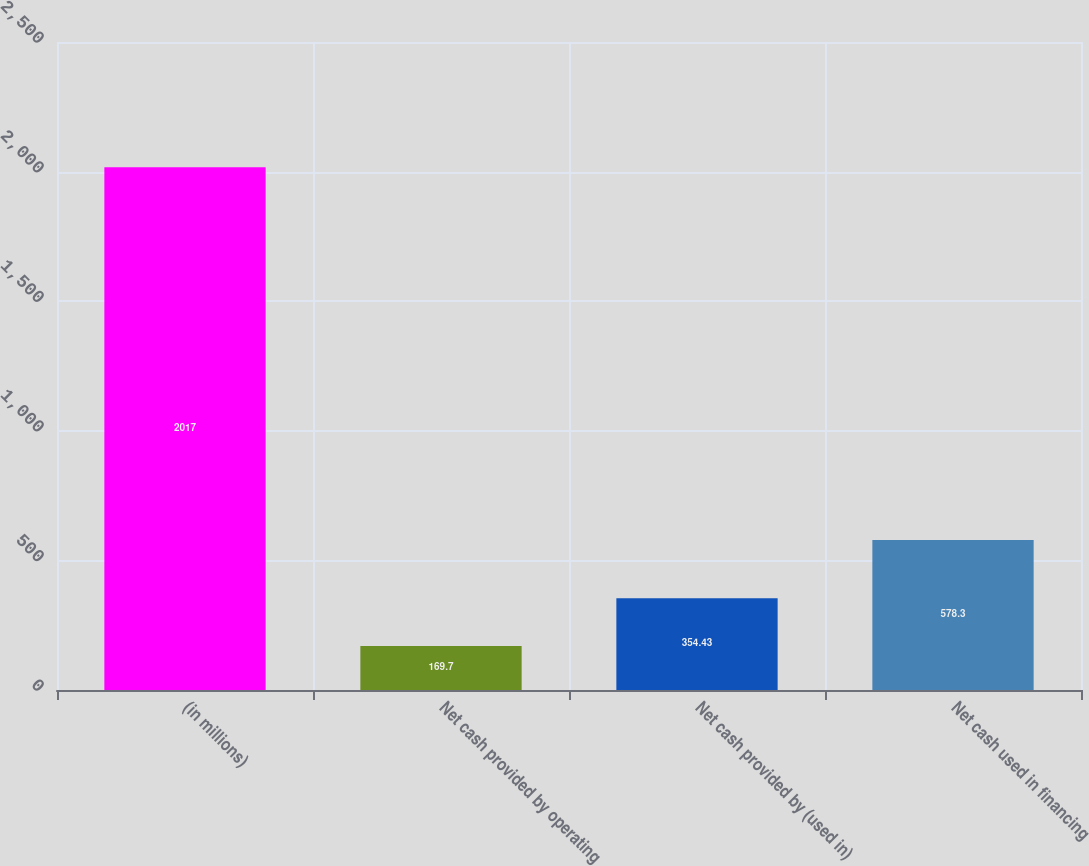<chart> <loc_0><loc_0><loc_500><loc_500><bar_chart><fcel>(in millions)<fcel>Net cash provided by operating<fcel>Net cash provided by (used in)<fcel>Net cash used in financing<nl><fcel>2017<fcel>169.7<fcel>354.43<fcel>578.3<nl></chart> 